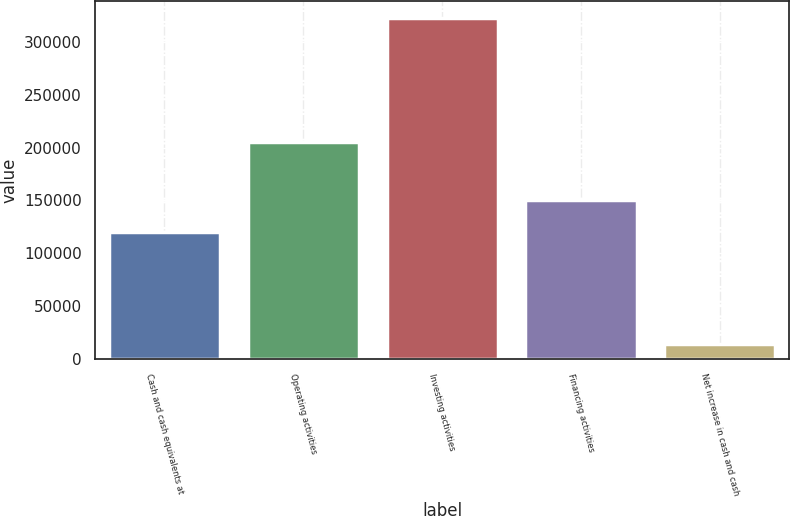Convert chart. <chart><loc_0><loc_0><loc_500><loc_500><bar_chart><fcel>Cash and cash equivalents at<fcel>Operating activities<fcel>Investing activities<fcel>Financing activities<fcel>Net increase in cash and cash<nl><fcel>119725<fcel>205211<fcel>322681<fcel>150574<fcel>14192<nl></chart> 